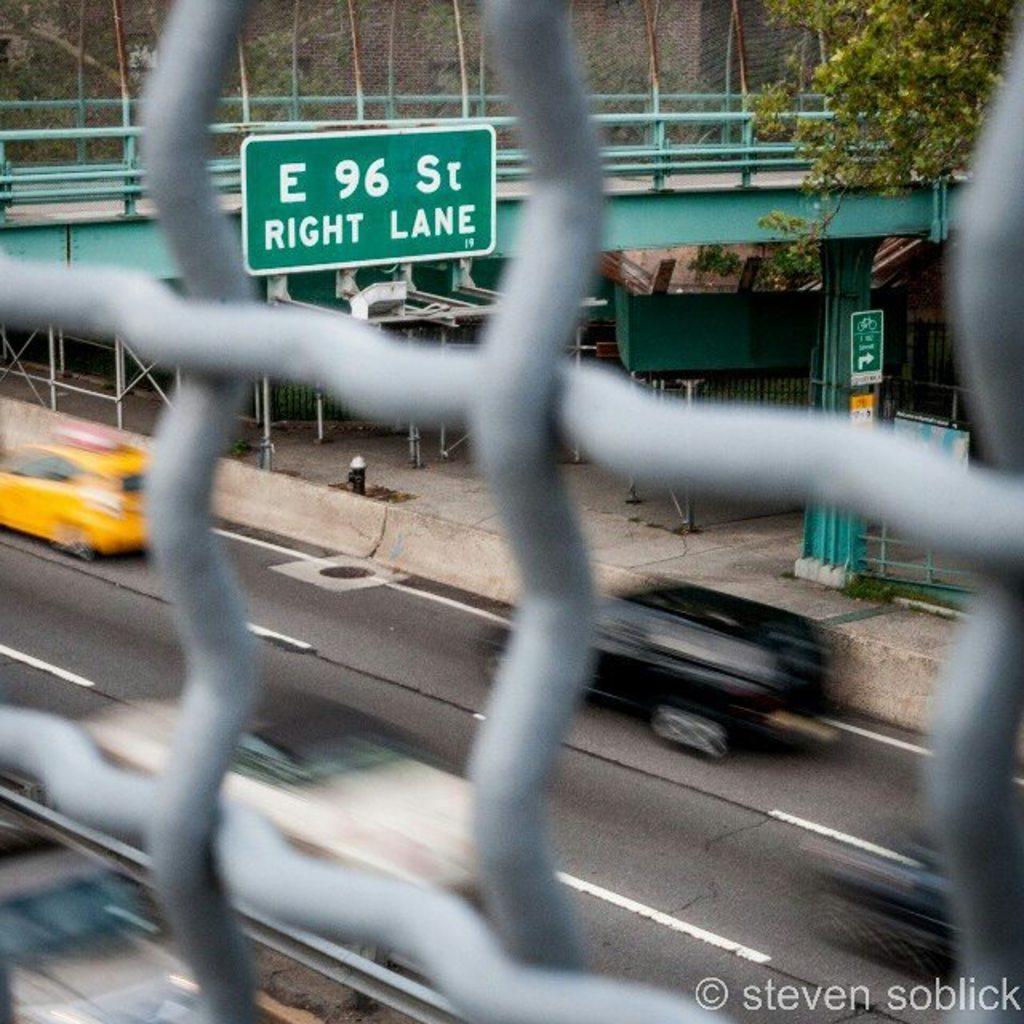Describe this image in one or two sentences. In this image in the front there is a grill. In the background there are cars moving on the road and there is a boat with some text written on it and there is a tree, there is a bridge and there is a person. 